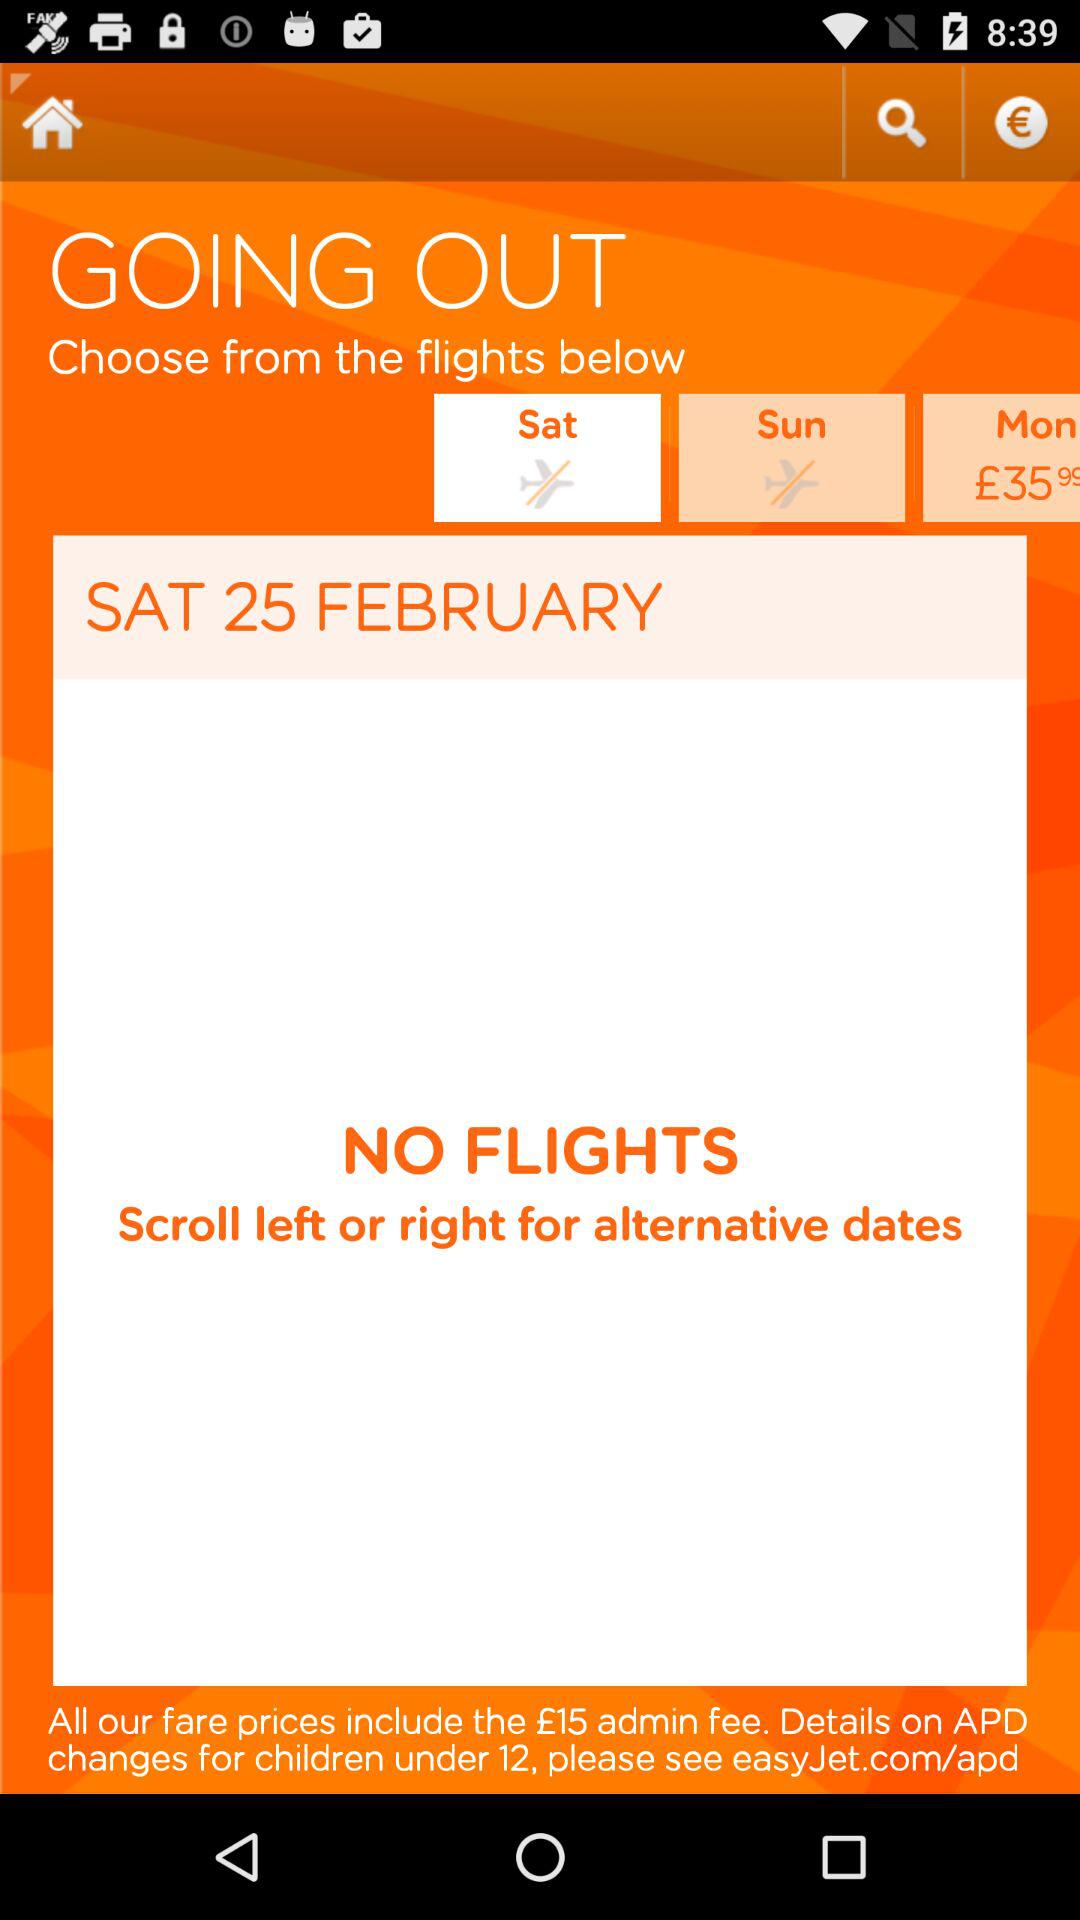How many flights are available on Saturday?
Answer the question using a single word or phrase. 0 